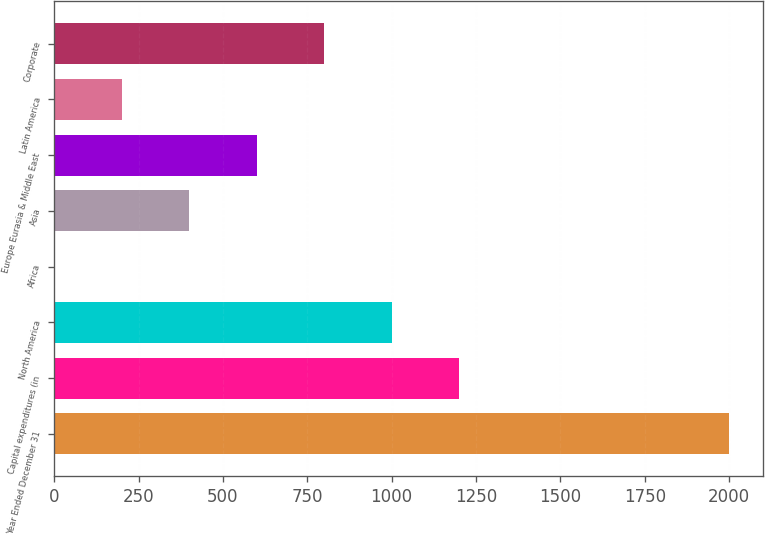Convert chart. <chart><loc_0><loc_0><loc_500><loc_500><bar_chart><fcel>Year Ended December 31<fcel>Capital expenditures (in<fcel>North America<fcel>Africa<fcel>Asia<fcel>Europe Eurasia & Middle East<fcel>Latin America<fcel>Corporate<nl><fcel>2001<fcel>1201<fcel>1001<fcel>1<fcel>401<fcel>601<fcel>201<fcel>801<nl></chart> 